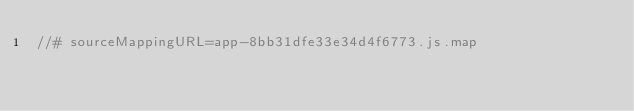Convert code to text. <code><loc_0><loc_0><loc_500><loc_500><_JavaScript_>//# sourceMappingURL=app-8bb31dfe33e34d4f6773.js.map</code> 